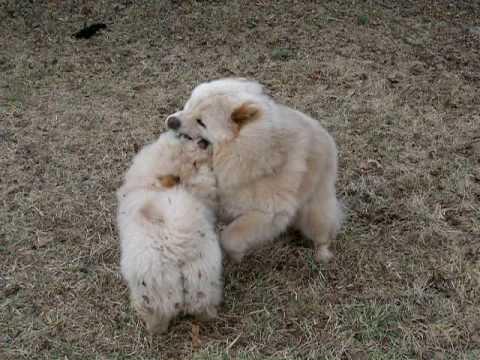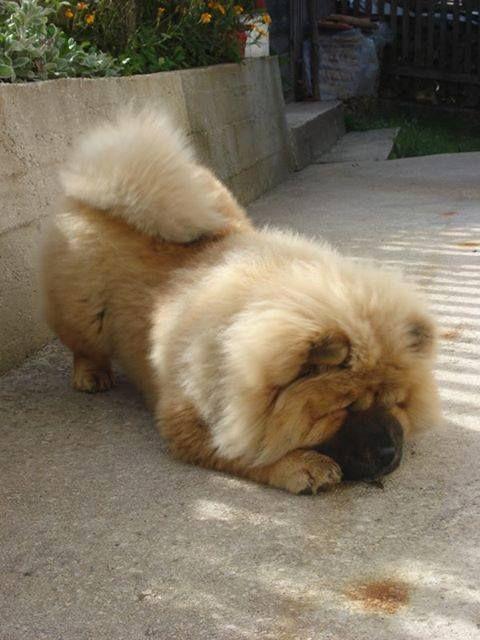The first image is the image on the left, the second image is the image on the right. Considering the images on both sides, is "One of the images shows only one dog." valid? Answer yes or no. Yes. 